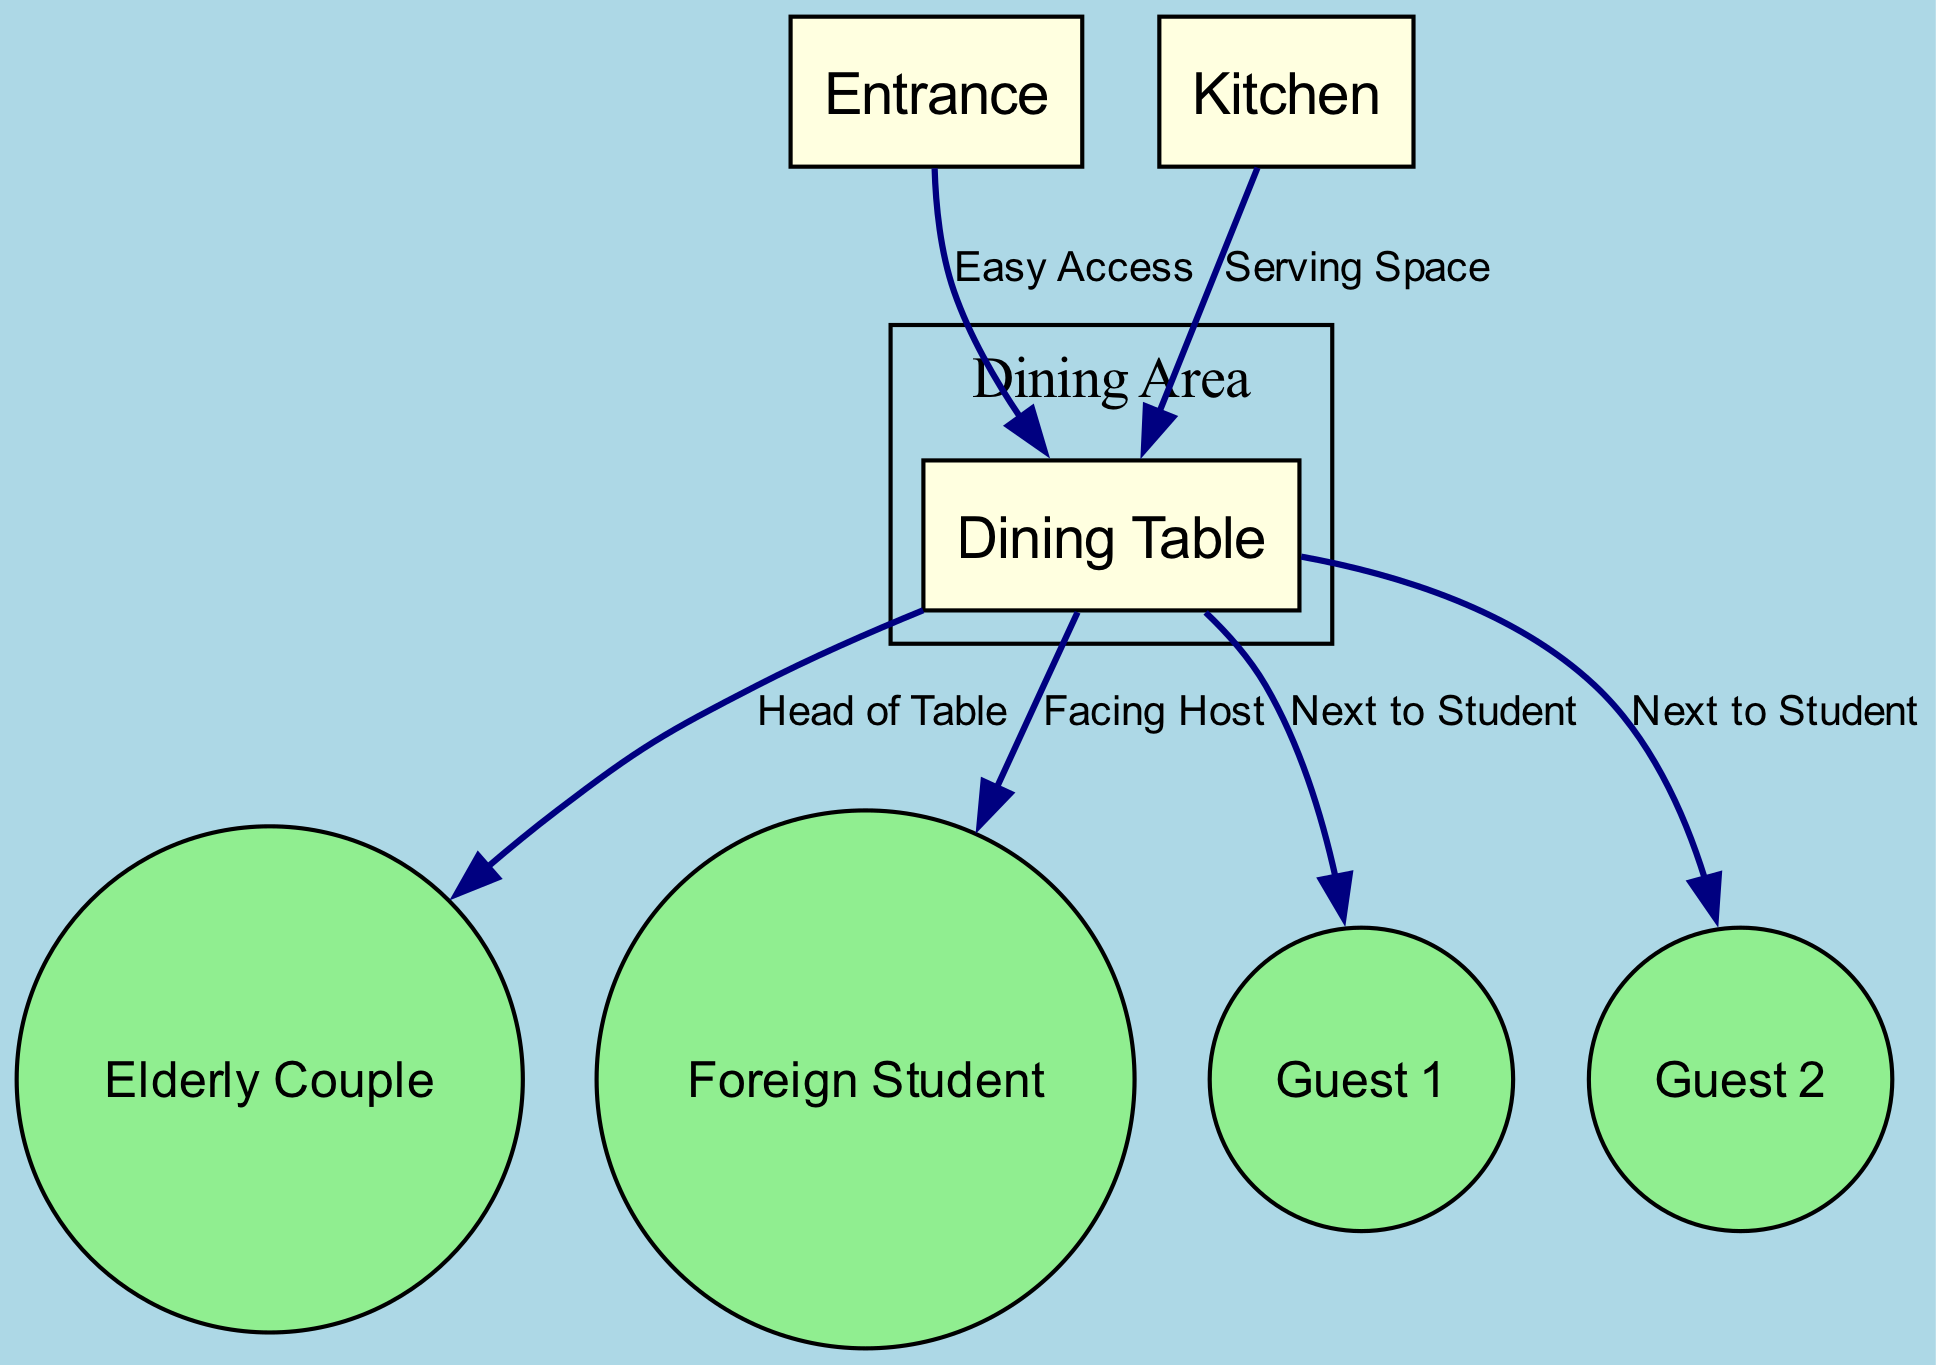What is the shape of the dining table? The dining table is depicted as a rectangle in the diagram. This shape is a standard representation of a dining table in seating arrangement diagrams.
Answer: rectangle Who is seated at the head of the table? The label "Head of Table" connects the dining table to the "Elderly Couple," indicating that they occupy this prestigious position at the meal. This is a conventional arrangement for hosts.
Answer: Elderly Couple How many guests are sitting next to the foreign student? The diagram shows two connections labeled "Next to Student," indicating there are two guests seated adjacent to the foreign student, fostering conversation.
Answer: 2 What is the relationship between the entrance and the dining table? The edge labeled "Easy Access" connects the entrance to the dining table, demonstrating that guests can easily reach the dining area upon entering.
Answer: Easy Access Where is the kitchen located in relation to the table? A connection labeled "Serving Space" links the kitchen to the dining table, indicating an area for serving food and making it convenient during the meal.
Answer: Serving Space What is the total number of nodes in the diagram? By counting the items listed in the nodes section, there are a total of seven nodes, which includes the table, the elderly couple, the foreign student, two guests, and two rectangles for the entrance and kitchen.
Answer: 7 Which guest is positioned next to guest 1? The relationships show that guest 1 is seated next to the foreign student and there is no additional guest next to guest 1. Guest 2 is also seated next to the student but not beside guest 1.
Answer: None What type of diagram is this? The structure and content of the diagram are indicative of a seating arrangement, often used to visualize social interactions and placements during gatherings.
Answer: Textbook Diagram How far apart are the elderly couple and the kitchen? The diagram illustrates the kitchen on one side and the elderly couple seated at the table; the distance can be interpreted as an indirect relationship since the kitchen is for serving and not directly next to any person.
Answer: Indirect Relationship 